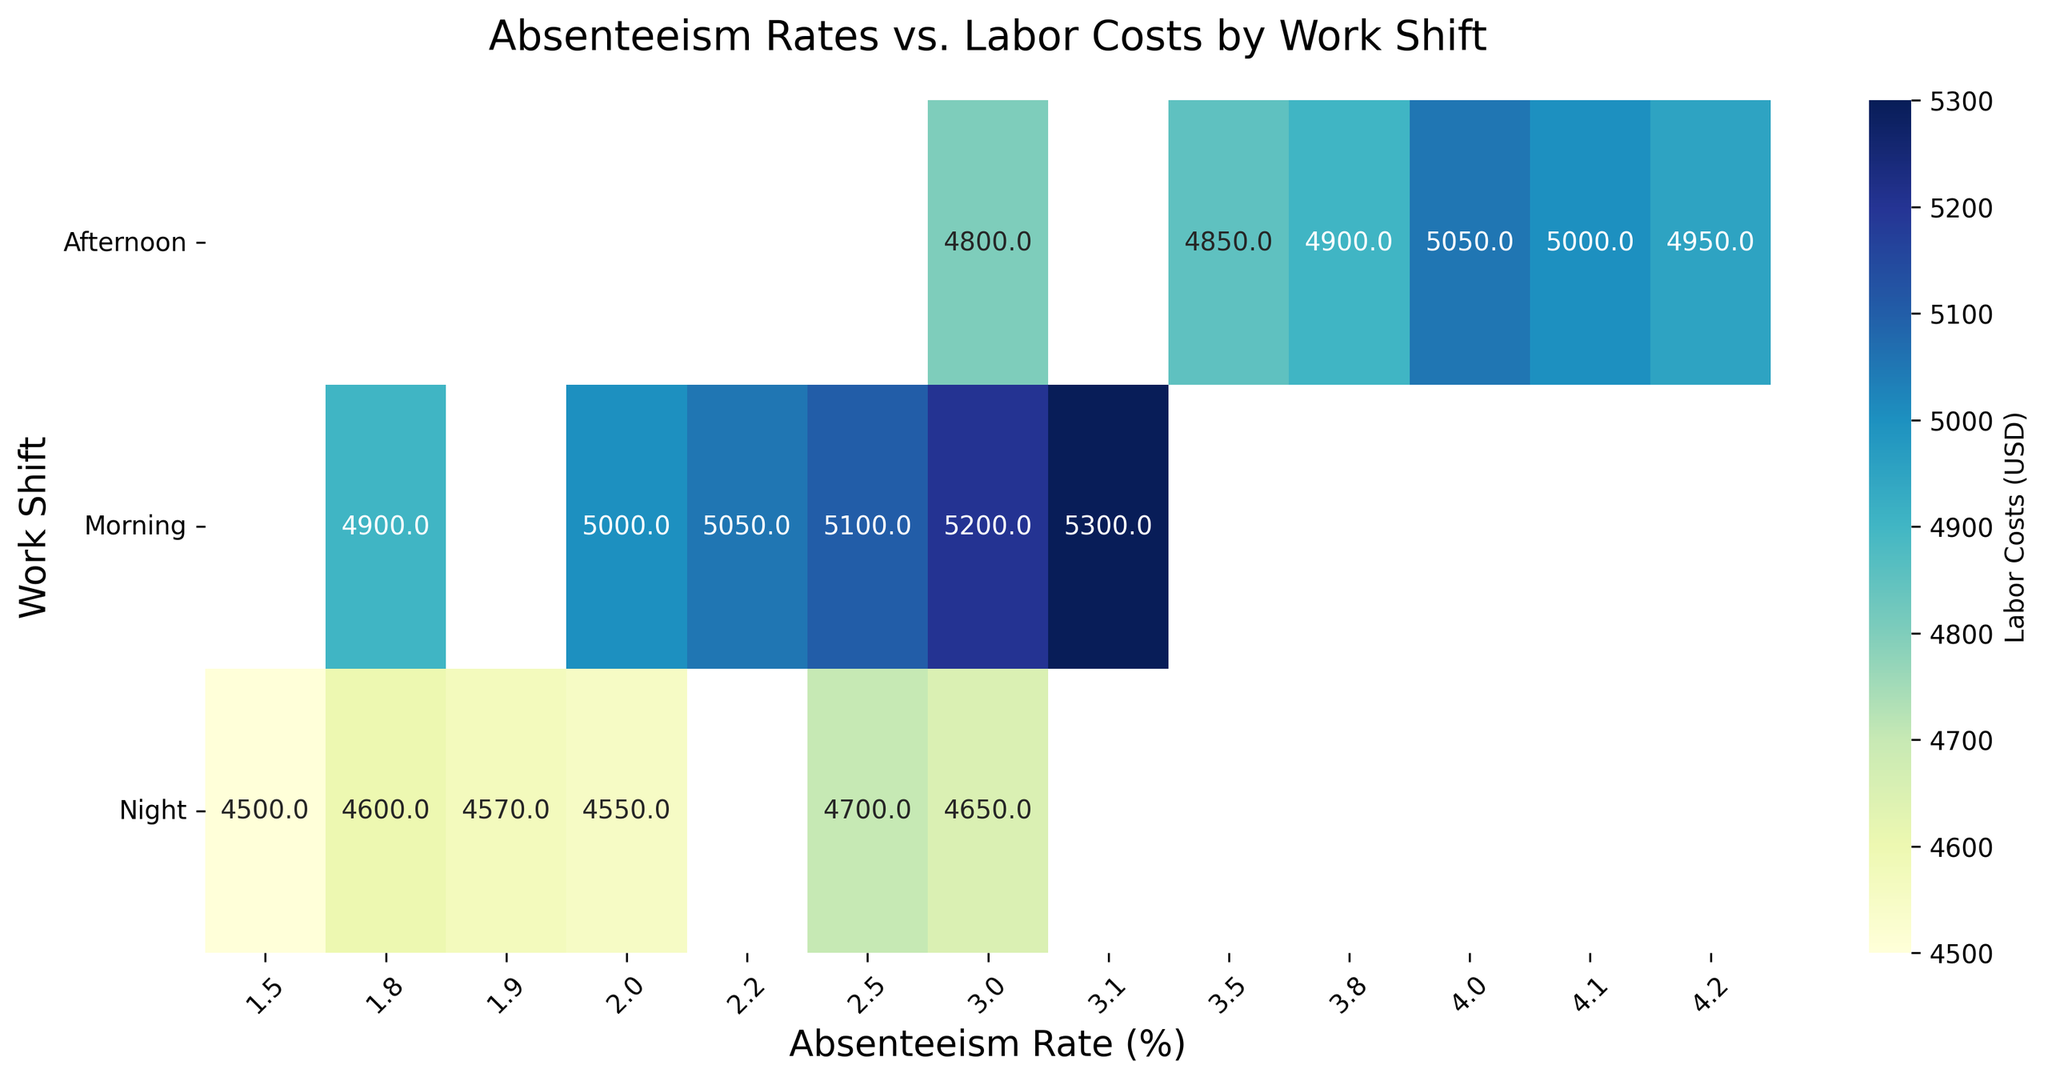What's the highest labor cost recorded for the Morning shift? Look at the heatmap under the "Morning" row and identify the highest value in the Labor Costs. The highest value in this row represents the maximum labor cost recorded for the Morning shift.
Answer: 5300 Which work shift has the lowest absenteeism rate? Identify the lowest value in the "Absenteeism Rate (%)" columns and check which work shift corresponds to this rate on the heatmap.
Answer: Morning Among all shifts, which has the highest average labor cost at absenteeism rates of 3%? Check the values in the columns marked as 3% absenteeism rate. Calculate the average for each work shift. The shift with the highest calculated average is the answer.
Answer: Morning For the Afternoon shift, what's the range of labor costs? Find the minimum and maximum labor costs in the "Afternoon" row on the heatmap. Subtract the minimum from the maximum to get the range.
Answer: 250 What are the absenteeism rate ranges where labor costs for the Night shift are between 4500 and 4600 USD? Identify the columns under the "Night" row with labor costs between 4500 and 4600 USD. Note the corresponding absenteeism rates.
Answer: 1.5% to 2.5% Is there any absenteesim rate where labor costs are higher in the Night shift compared to the Morning shift? Compare the values in each column for the Morning and Night rows. Identify if any labor cost in the "Night" row is higher than the corresponding value in the "Morning" row for any absenteeism rate.
Answer: No What's the difference in labor costs for absenteeism rates of 2% and 3% for the Morning shift? Locate the labor costs for 2% and 3% absenteeism rates in the "Morning" row. Subtract the 2% labor cost from the 3% labor cost.
Answer: 300 Comparing all shifts, which shift exhibits the highest labor cost at a 4% absenteeism rate? Check the values under the 4% absenteeism rate column for all shifts. The highest value indicates the shift with the highest labor cost for that rate.
Answer: Afternoon Is there any absenteeism rate where the Morning shift has the minimum labor cost among all the shifts? For each absenteeism rate column, identify if the "Morning" row has the smallest value compared to "Afternoon" and "Night" rows.
Answer: Yes, at 1.8% What's the average labor cost for the Afternoon shift at absenteeism rates between 3% and 4%? Identify the labor costs for 3%, 3.5%, 3.8%, 4% absenteeism rates in the "Afternoon" row. Sum these values and divide by the number of data points (4).
Answer: 4950 